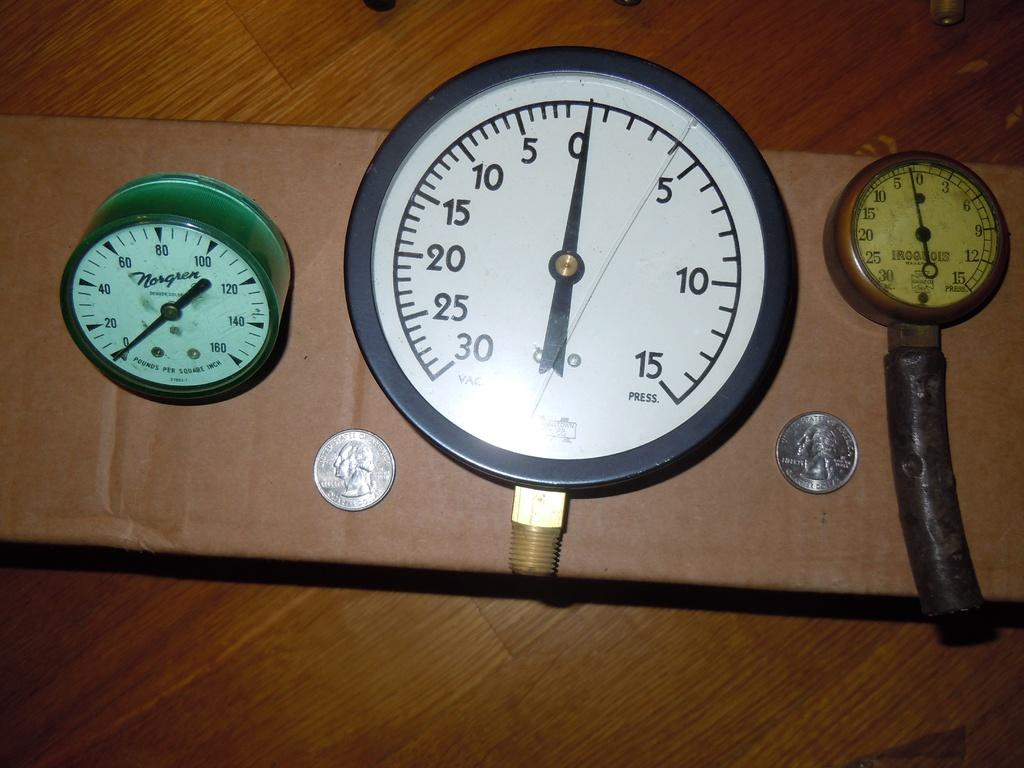What's the highest number shown on the middle device?
Give a very brief answer. 30. What is the lowest number shown on the middle device?
Keep it short and to the point. 0. 